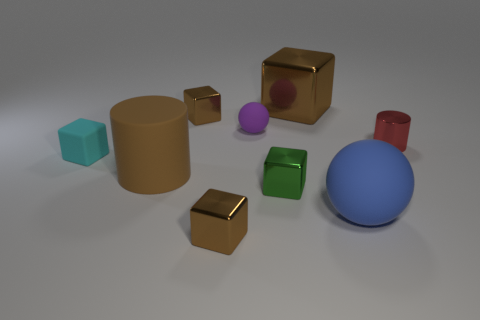Does the rubber cylinder have the same color as the large metal object?
Offer a terse response. Yes. Are any cyan metallic cylinders visible?
Keep it short and to the point. No. Is the number of rubber cubes less than the number of tiny brown shiny cubes?
Provide a succinct answer. Yes. What number of small green blocks have the same material as the big block?
Your response must be concise. 1. The cylinder that is the same material as the cyan object is what color?
Provide a succinct answer. Brown. There is a red thing; what shape is it?
Your response must be concise. Cylinder. How many big things are the same color as the tiny cylinder?
Your answer should be very brief. 0. What is the shape of the shiny object that is the same size as the blue sphere?
Your answer should be compact. Cube. Is there a cyan block of the same size as the red thing?
Give a very brief answer. Yes. There is a cyan thing that is the same size as the purple rubber ball; what material is it?
Offer a terse response. Rubber. 